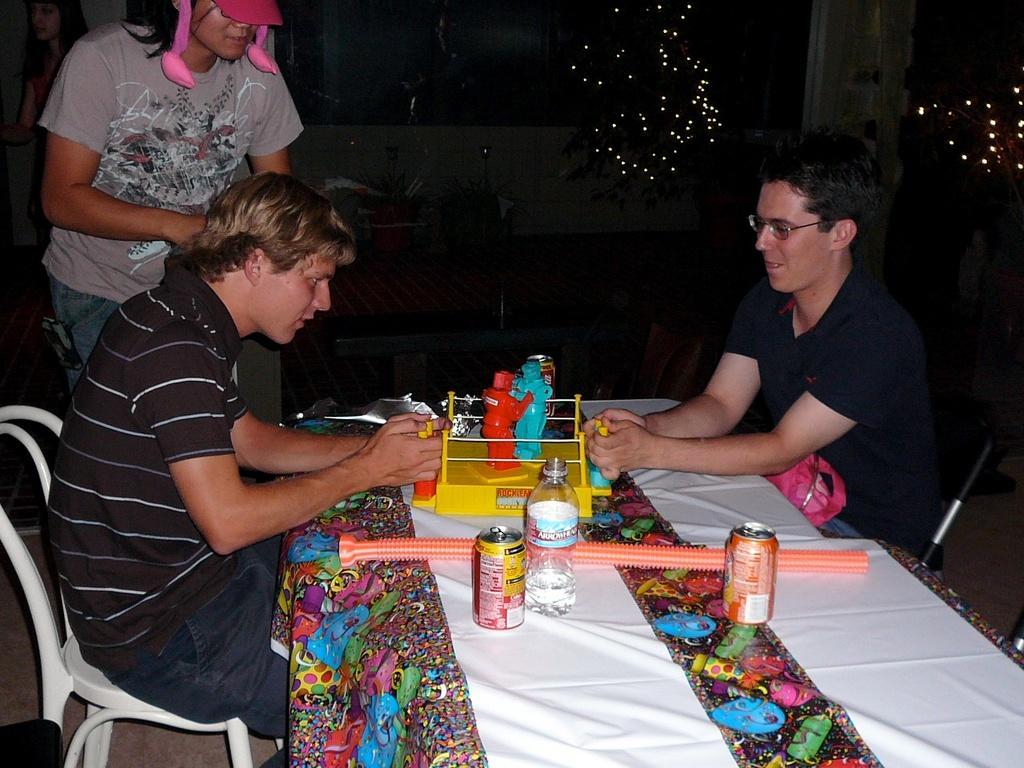Please provide a concise description of this image. In the center of the image there is a table and we can see a bottle, tins and toys placed on the table. On the left we can see a man sitting and playing, behind him there is a lady standing. In the background there is a mesh, trees, lights and plants. On the right we can see a man sitting on the chair. 